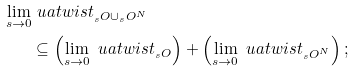Convert formula to latex. <formula><loc_0><loc_0><loc_500><loc_500>\lim _ { s \to 0 } & \ u a t w i s t _ { _ { s } O \cup _ { s } O ^ { N } } \\ & \subseteq \left ( \lim _ { s \to 0 } \ u a t w i s t _ { _ { s } O } \right ) + \left ( \lim _ { s \to 0 } \ u a t w i s t _ { _ { s } O ^ { N } } \right ) ;</formula> 